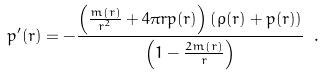Convert formula to latex. <formula><loc_0><loc_0><loc_500><loc_500>p ^ { \prime } ( r ) = - \frac { \left ( \frac { m ( r ) } { r ^ { 2 } } + 4 \pi r p ( r ) \right ) \left ( \rho ( r ) + p ( r ) \right ) } { \left ( 1 - \frac { 2 m ( r ) } { r } \right ) } \ .</formula> 